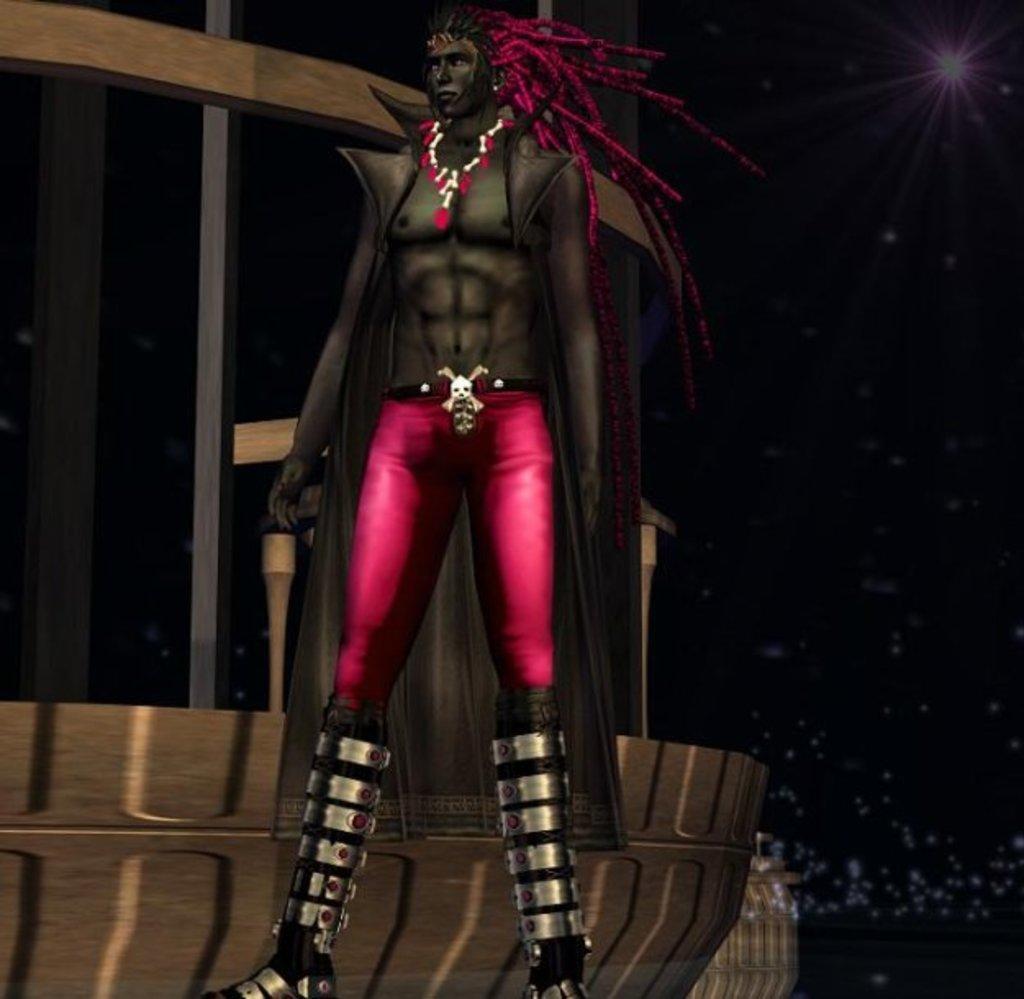Can you describe this image briefly? In this picture there is a cartoon of a man. He is wearing a pink trousers and an ornament. In the background, there is a building. 